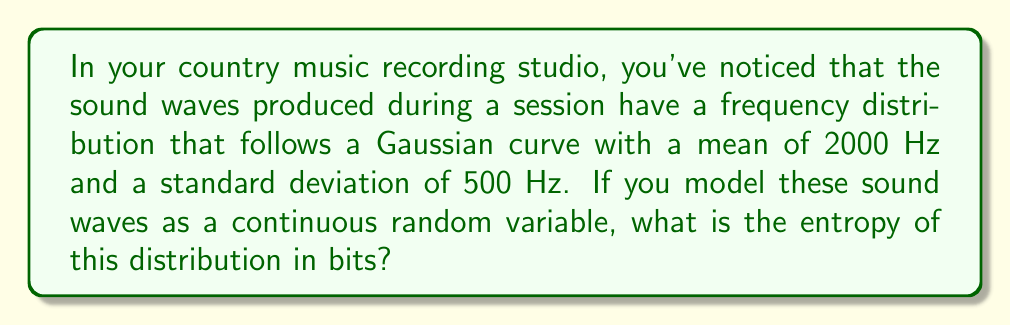Can you solve this math problem? Let's approach this step-by-step:

1) For a continuous random variable with a Gaussian (normal) distribution, the entropy is given by:

   $$H = \frac{1}{2} \log_2(2\pi e \sigma^2)$$

   where $\sigma$ is the standard deviation.

2) We're given that $\sigma = 500$ Hz.

3) Let's substitute this into our equation:

   $$H = \frac{1}{2} \log_2(2\pi e (500)^2)$$

4) Simplify inside the parentheses:

   $$H = \frac{1}{2} \log_2(2\pi e \cdot 250000)$$

5) Calculate the value inside the parentheses:
   
   $$H = \frac{1}{2} \log_2(1570796.33)$$

6) Now, we can calculate the logarithm:

   $$H = \frac{1}{2} \cdot 20.584 = 10.292$$

7) Therefore, the entropy is approximately 10.292 bits.
Answer: 10.292 bits 